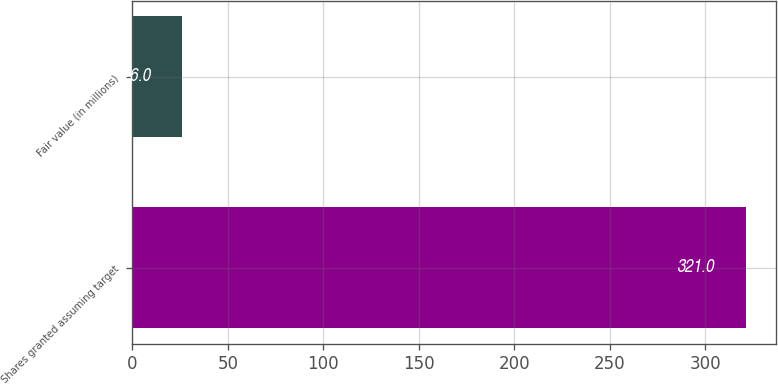Convert chart. <chart><loc_0><loc_0><loc_500><loc_500><bar_chart><fcel>Shares granted assuming target<fcel>Fair value (in millions)<nl><fcel>321<fcel>26<nl></chart> 